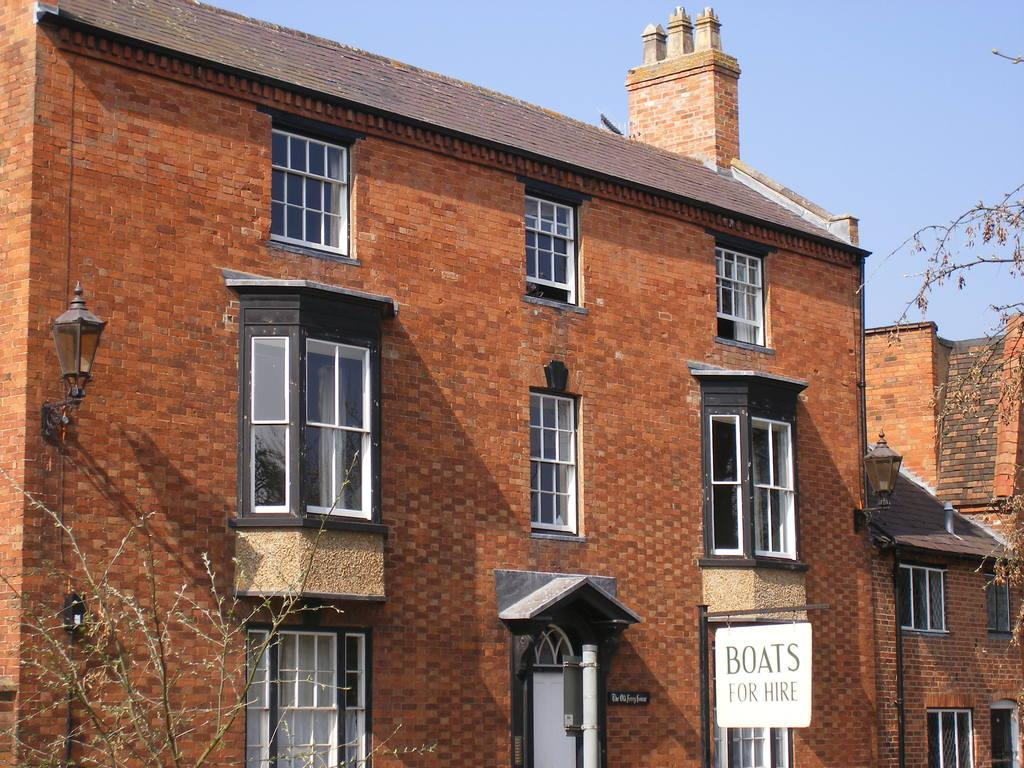What type of structures can be seen in the image? There are buildings with windows in the image. What other elements are present in the image besides the buildings? There are trees and a name board in the image. What can be seen in the background of the image? The sky is visible in the background of the image. What type of copper pot can be seen hanging from the trees in the image? There is no copper pot present in the image, nor are there any pots hanging from the trees. 